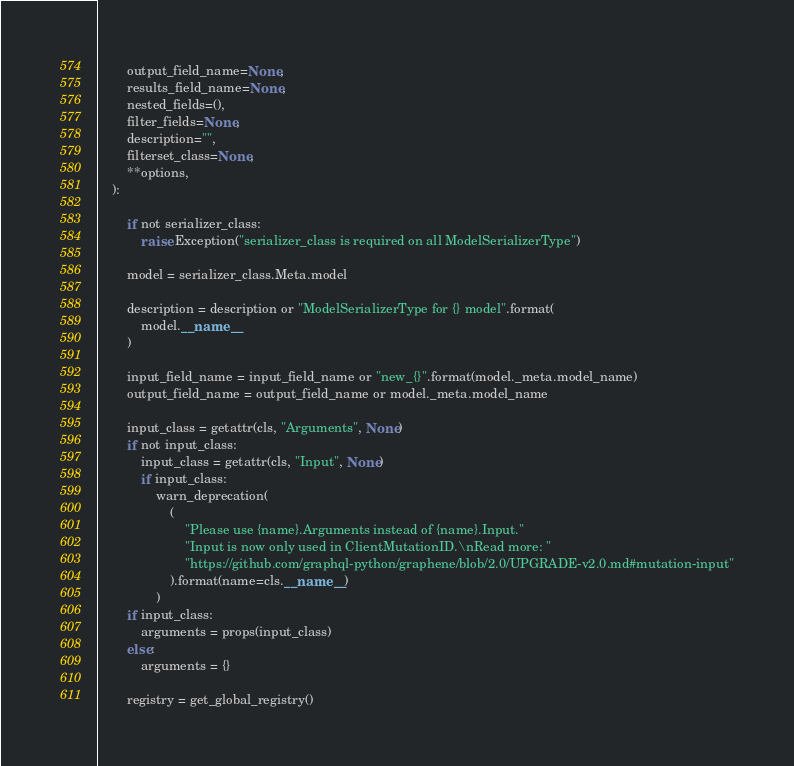Convert code to text. <code><loc_0><loc_0><loc_500><loc_500><_Python_>        output_field_name=None,
        results_field_name=None,
        nested_fields=(),
        filter_fields=None,
        description="",
        filterset_class=None,
        **options,
    ):

        if not serializer_class:
            raise Exception("serializer_class is required on all ModelSerializerType")

        model = serializer_class.Meta.model

        description = description or "ModelSerializerType for {} model".format(
            model.__name__
        )

        input_field_name = input_field_name or "new_{}".format(model._meta.model_name)
        output_field_name = output_field_name or model._meta.model_name

        input_class = getattr(cls, "Arguments", None)
        if not input_class:
            input_class = getattr(cls, "Input", None)
            if input_class:
                warn_deprecation(
                    (
                        "Please use {name}.Arguments instead of {name}.Input."
                        "Input is now only used in ClientMutationID.\nRead more: "
                        "https://github.com/graphql-python/graphene/blob/2.0/UPGRADE-v2.0.md#mutation-input"
                    ).format(name=cls.__name__)
                )
        if input_class:
            arguments = props(input_class)
        else:
            arguments = {}

        registry = get_global_registry()
</code> 